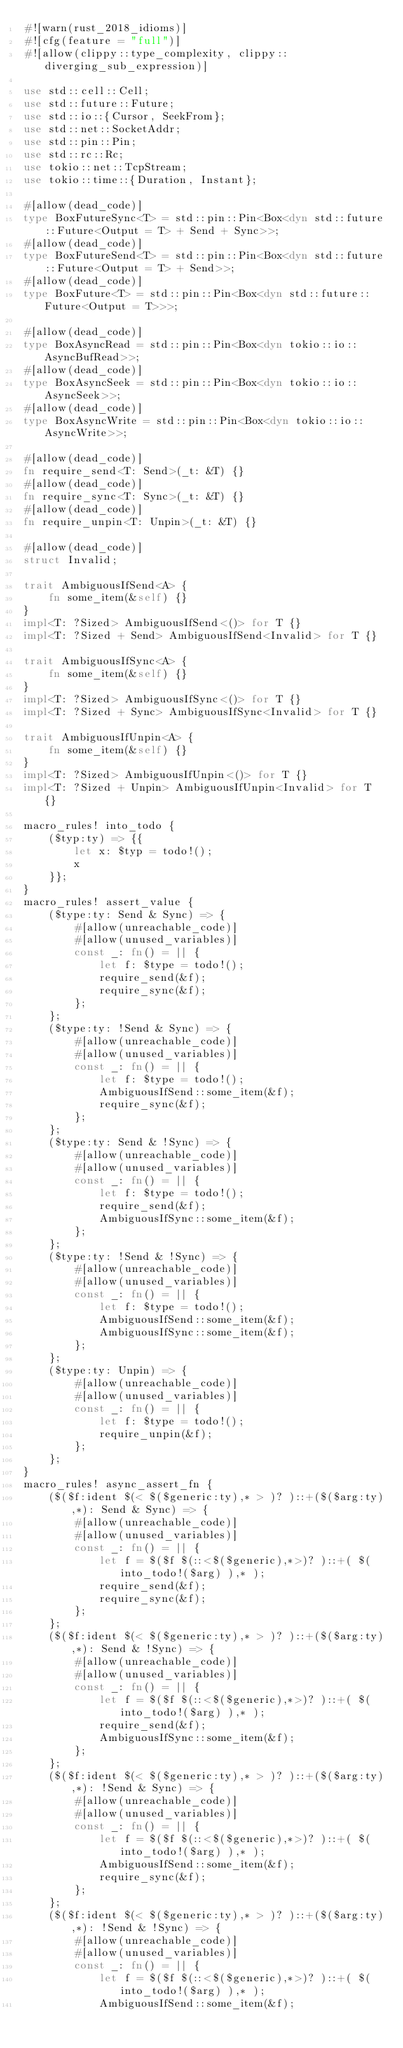<code> <loc_0><loc_0><loc_500><loc_500><_Rust_>#![warn(rust_2018_idioms)]
#![cfg(feature = "full")]
#![allow(clippy::type_complexity, clippy::diverging_sub_expression)]

use std::cell::Cell;
use std::future::Future;
use std::io::{Cursor, SeekFrom};
use std::net::SocketAddr;
use std::pin::Pin;
use std::rc::Rc;
use tokio::net::TcpStream;
use tokio::time::{Duration, Instant};

#[allow(dead_code)]
type BoxFutureSync<T> = std::pin::Pin<Box<dyn std::future::Future<Output = T> + Send + Sync>>;
#[allow(dead_code)]
type BoxFutureSend<T> = std::pin::Pin<Box<dyn std::future::Future<Output = T> + Send>>;
#[allow(dead_code)]
type BoxFuture<T> = std::pin::Pin<Box<dyn std::future::Future<Output = T>>>;

#[allow(dead_code)]
type BoxAsyncRead = std::pin::Pin<Box<dyn tokio::io::AsyncBufRead>>;
#[allow(dead_code)]
type BoxAsyncSeek = std::pin::Pin<Box<dyn tokio::io::AsyncSeek>>;
#[allow(dead_code)]
type BoxAsyncWrite = std::pin::Pin<Box<dyn tokio::io::AsyncWrite>>;

#[allow(dead_code)]
fn require_send<T: Send>(_t: &T) {}
#[allow(dead_code)]
fn require_sync<T: Sync>(_t: &T) {}
#[allow(dead_code)]
fn require_unpin<T: Unpin>(_t: &T) {}

#[allow(dead_code)]
struct Invalid;

trait AmbiguousIfSend<A> {
    fn some_item(&self) {}
}
impl<T: ?Sized> AmbiguousIfSend<()> for T {}
impl<T: ?Sized + Send> AmbiguousIfSend<Invalid> for T {}

trait AmbiguousIfSync<A> {
    fn some_item(&self) {}
}
impl<T: ?Sized> AmbiguousIfSync<()> for T {}
impl<T: ?Sized + Sync> AmbiguousIfSync<Invalid> for T {}

trait AmbiguousIfUnpin<A> {
    fn some_item(&self) {}
}
impl<T: ?Sized> AmbiguousIfUnpin<()> for T {}
impl<T: ?Sized + Unpin> AmbiguousIfUnpin<Invalid> for T {}

macro_rules! into_todo {
    ($typ:ty) => {{
        let x: $typ = todo!();
        x
    }};
}
macro_rules! assert_value {
    ($type:ty: Send & Sync) => {
        #[allow(unreachable_code)]
        #[allow(unused_variables)]
        const _: fn() = || {
            let f: $type = todo!();
            require_send(&f);
            require_sync(&f);
        };
    };
    ($type:ty: !Send & Sync) => {
        #[allow(unreachable_code)]
        #[allow(unused_variables)]
        const _: fn() = || {
            let f: $type = todo!();
            AmbiguousIfSend::some_item(&f);
            require_sync(&f);
        };
    };
    ($type:ty: Send & !Sync) => {
        #[allow(unreachable_code)]
        #[allow(unused_variables)]
        const _: fn() = || {
            let f: $type = todo!();
            require_send(&f);
            AmbiguousIfSync::some_item(&f);
        };
    };
    ($type:ty: !Send & !Sync) => {
        #[allow(unreachable_code)]
        #[allow(unused_variables)]
        const _: fn() = || {
            let f: $type = todo!();
            AmbiguousIfSend::some_item(&f);
            AmbiguousIfSync::some_item(&f);
        };
    };
    ($type:ty: Unpin) => {
        #[allow(unreachable_code)]
        #[allow(unused_variables)]
        const _: fn() = || {
            let f: $type = todo!();
            require_unpin(&f);
        };
    };
}
macro_rules! async_assert_fn {
    ($($f:ident $(< $($generic:ty),* > )? )::+($($arg:ty),*): Send & Sync) => {
        #[allow(unreachable_code)]
        #[allow(unused_variables)]
        const _: fn() = || {
            let f = $($f $(::<$($generic),*>)? )::+( $( into_todo!($arg) ),* );
            require_send(&f);
            require_sync(&f);
        };
    };
    ($($f:ident $(< $($generic:ty),* > )? )::+($($arg:ty),*): Send & !Sync) => {
        #[allow(unreachable_code)]
        #[allow(unused_variables)]
        const _: fn() = || {
            let f = $($f $(::<$($generic),*>)? )::+( $( into_todo!($arg) ),* );
            require_send(&f);
            AmbiguousIfSync::some_item(&f);
        };
    };
    ($($f:ident $(< $($generic:ty),* > )? )::+($($arg:ty),*): !Send & Sync) => {
        #[allow(unreachable_code)]
        #[allow(unused_variables)]
        const _: fn() = || {
            let f = $($f $(::<$($generic),*>)? )::+( $( into_todo!($arg) ),* );
            AmbiguousIfSend::some_item(&f);
            require_sync(&f);
        };
    };
    ($($f:ident $(< $($generic:ty),* > )? )::+($($arg:ty),*): !Send & !Sync) => {
        #[allow(unreachable_code)]
        #[allow(unused_variables)]
        const _: fn() = || {
            let f = $($f $(::<$($generic),*>)? )::+( $( into_todo!($arg) ),* );
            AmbiguousIfSend::some_item(&f);</code> 